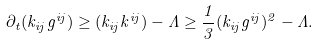Convert formula to latex. <formula><loc_0><loc_0><loc_500><loc_500>\partial _ { t } ( k _ { i j } g ^ { i j } ) \geq ( k _ { i j } k ^ { i j } ) - \Lambda \geq \frac { 1 } { 3 } ( k _ { i j } g ^ { i j } ) ^ { 2 } - \Lambda .</formula> 